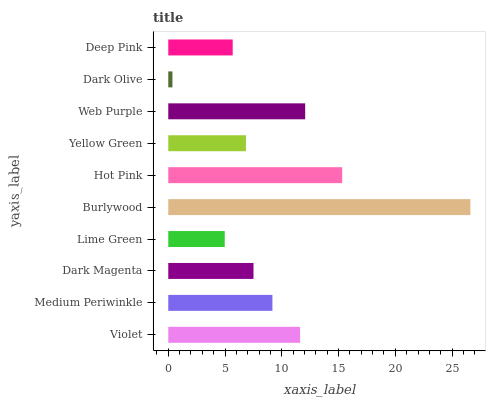Is Dark Olive the minimum?
Answer yes or no. Yes. Is Burlywood the maximum?
Answer yes or no. Yes. Is Medium Periwinkle the minimum?
Answer yes or no. No. Is Medium Periwinkle the maximum?
Answer yes or no. No. Is Violet greater than Medium Periwinkle?
Answer yes or no. Yes. Is Medium Periwinkle less than Violet?
Answer yes or no. Yes. Is Medium Periwinkle greater than Violet?
Answer yes or no. No. Is Violet less than Medium Periwinkle?
Answer yes or no. No. Is Medium Periwinkle the high median?
Answer yes or no. Yes. Is Dark Magenta the low median?
Answer yes or no. Yes. Is Dark Magenta the high median?
Answer yes or no. No. Is Dark Olive the low median?
Answer yes or no. No. 